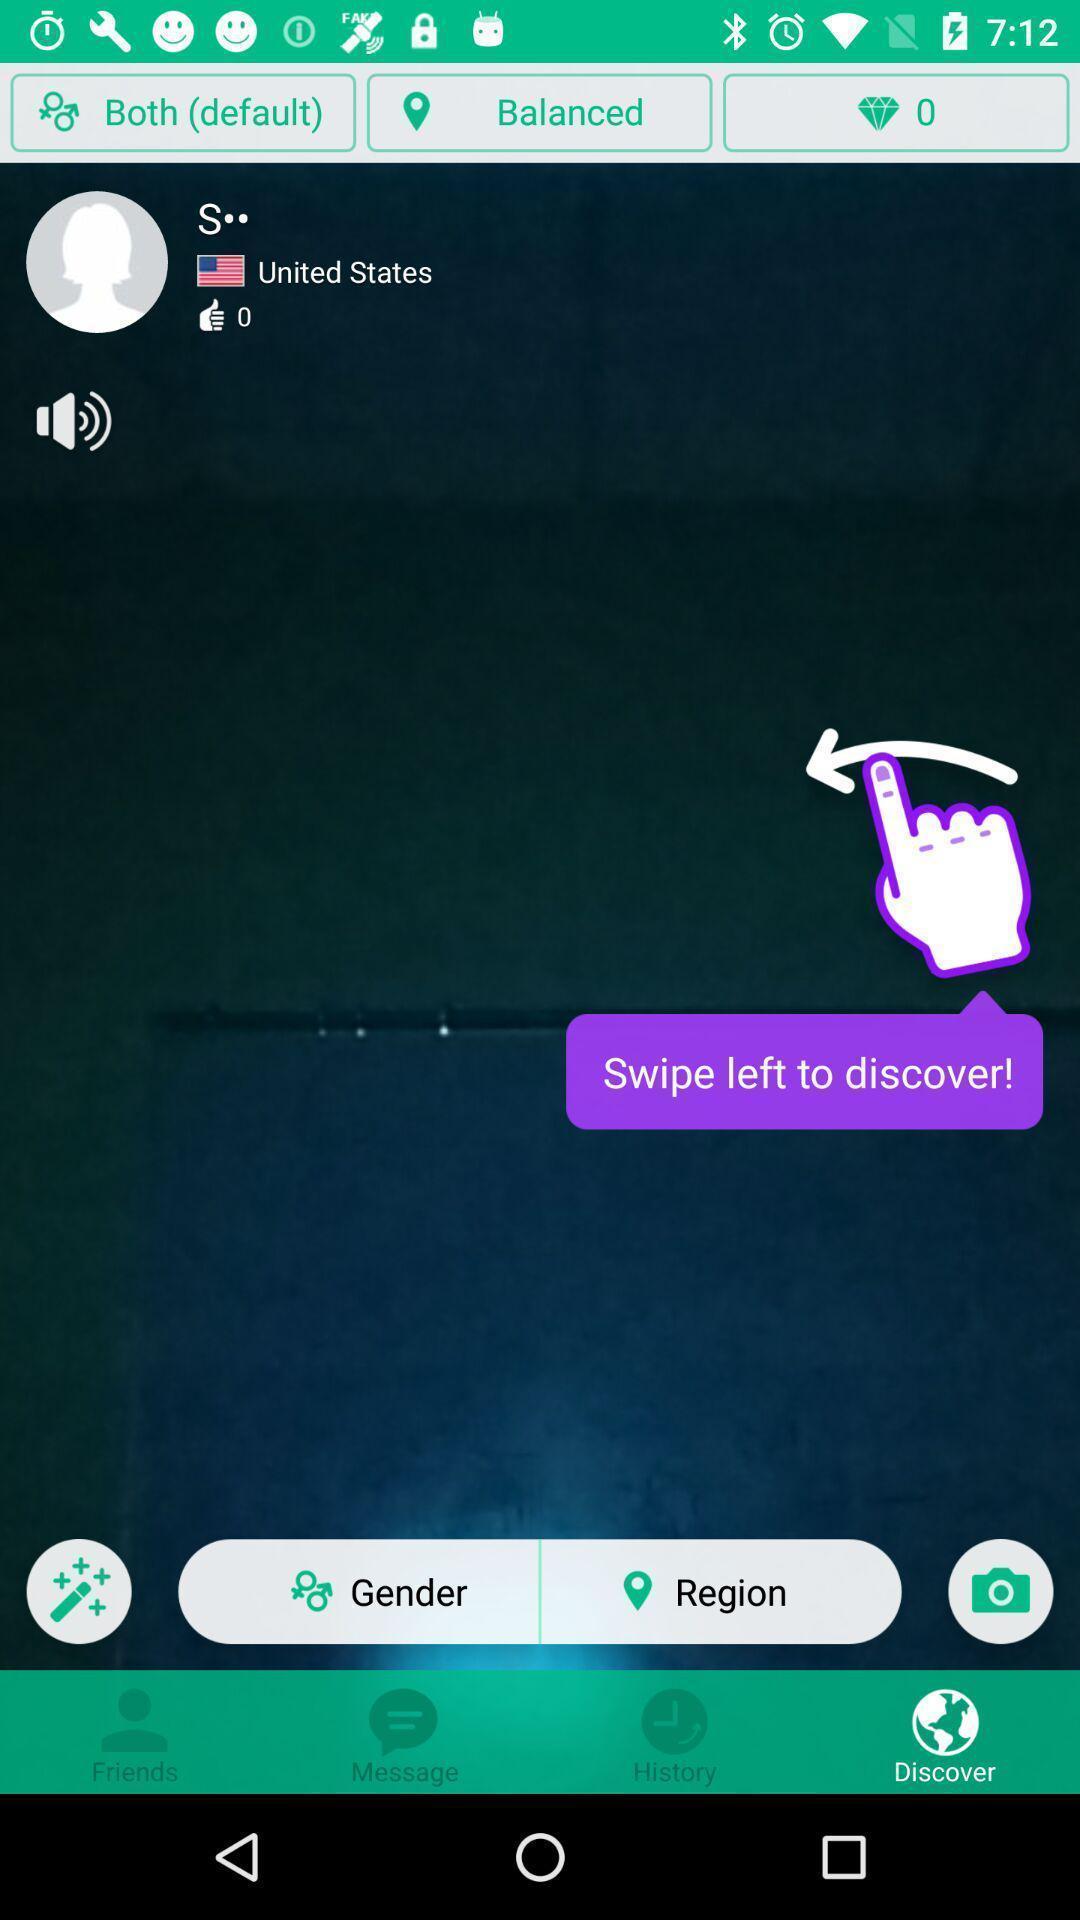Provide a detailed account of this screenshot. Screen showing various kinds of buttons. 